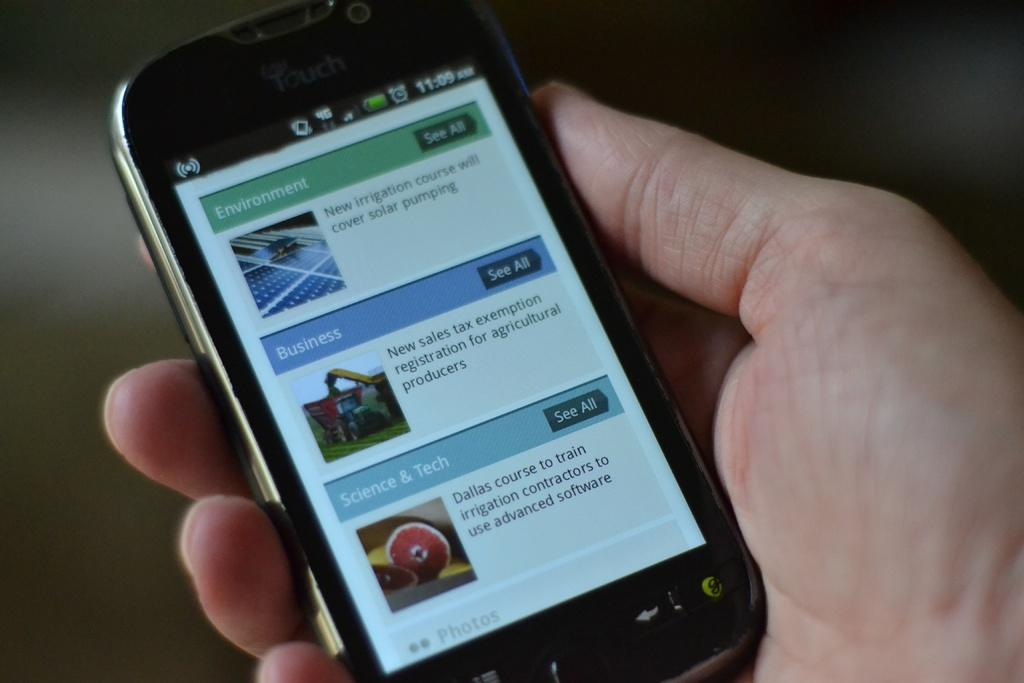Provide a one-sentence caption for the provided image. a hand holding a phone whose screen is displaying several types of articles like business and entertainment. 